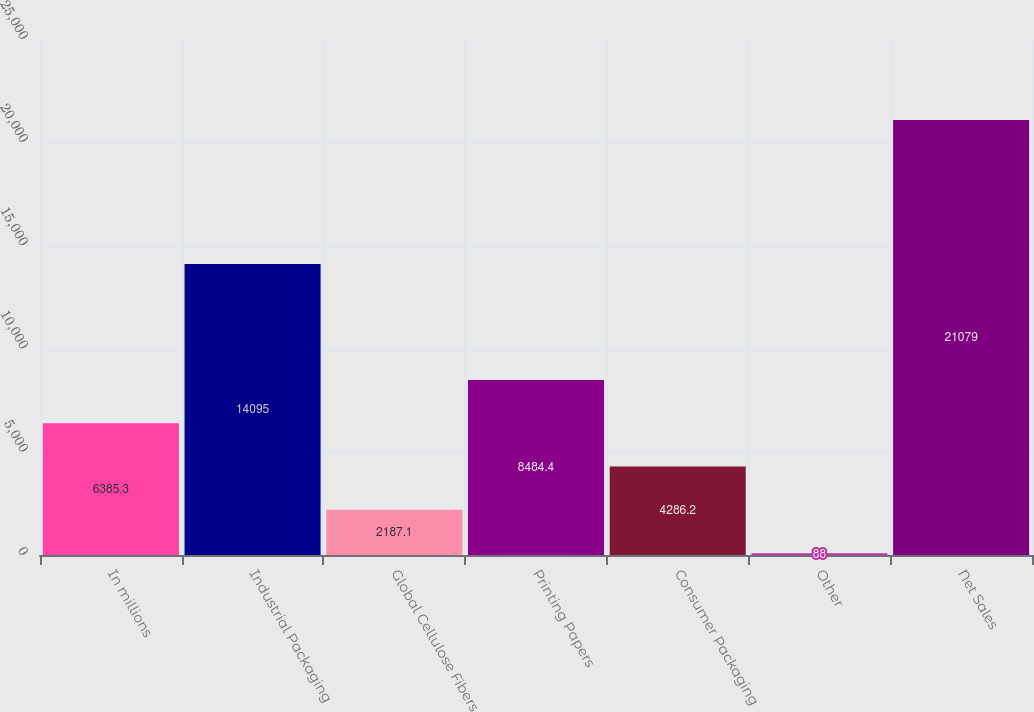<chart> <loc_0><loc_0><loc_500><loc_500><bar_chart><fcel>In millions<fcel>Industrial Packaging<fcel>Global Cellulose Fibers<fcel>Printing Papers<fcel>Consumer Packaging<fcel>Other<fcel>Net Sales<nl><fcel>6385.3<fcel>14095<fcel>2187.1<fcel>8484.4<fcel>4286.2<fcel>88<fcel>21079<nl></chart> 